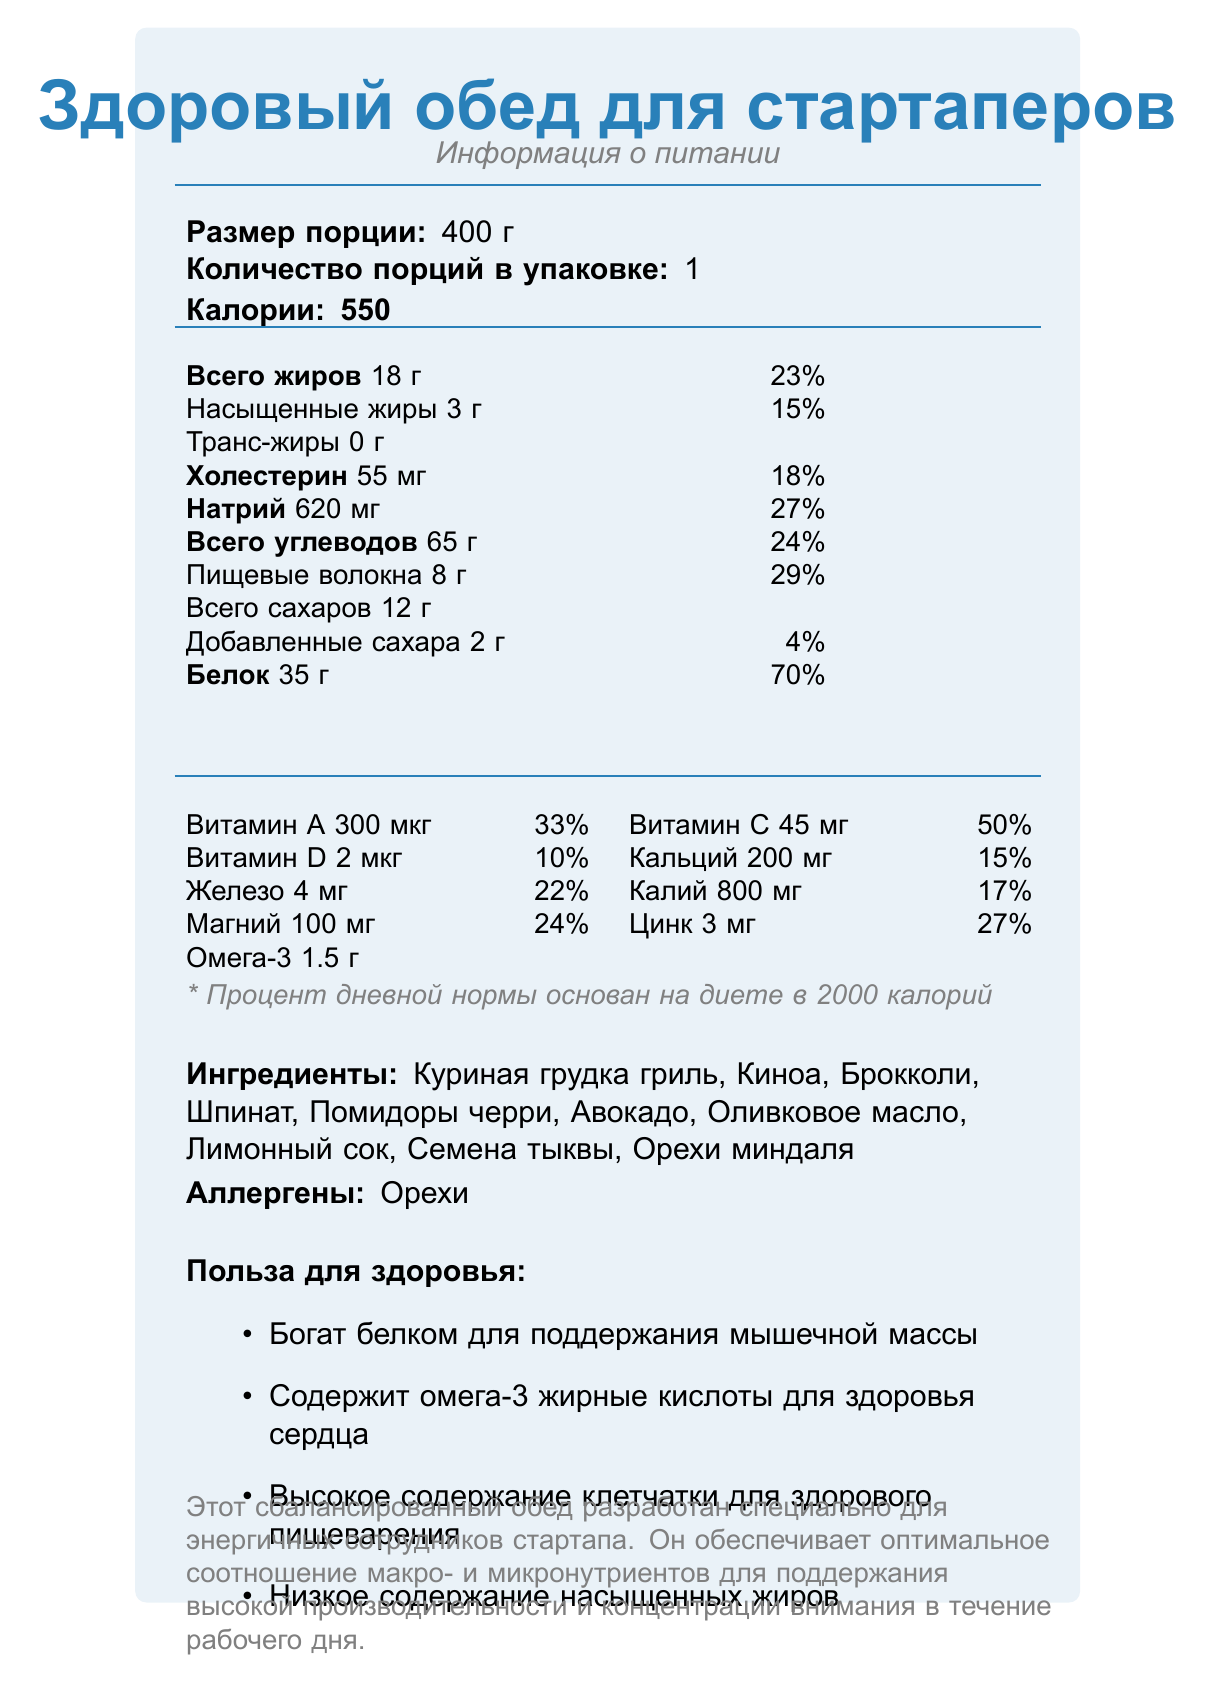what is the serving size? The label states that the serving size is 400 г.
Answer: 400 г how many calories does one serving contain? The document indicates that there are 550 calories per serving.
Answer: 550 what is the amount of protein in one serving? The label states that one serving contains 35 г of protein.
Answer: 35 г what percentage of vitamin C does one serving provide? The label shows that one serving provides 50% of the daily value for vitamin C.
Answer: 50% which ingredient might cause an allergic reaction? The list of allergens on the document includes "Орехи," which means nuts.
Answer: Орехи what is the amount of dietary fiber in one serving? The label indicates that each serving contains 8 г of dietary fiber.
Answer: 8 г what are the benefits of consuming this meal related to fiber content? A. High in protein B. High in fiber C. Contains omega-3 D. Low in calories The nutritional claims indicate a high fiber content for healthy digestion.
Answer: B how much magnesium is in one serving? A. 4 мг B. 100 мг C. 200 мг D. 50 мг The label shows that one serving contains 100 мг of magnesium.
Answer: B does this meal include any trans fats? The document explicitly states that this meal contains 0 г of trans fats.
Answer: No is this meal suitable for someone limiting their sodium intake? The meal contains 620 мг of sodium per serving, which is 27% of the daily recommended value, possibly making it unsuitable for someone limiting sodium intake.
Answer: No what are the ingredients of this meal? The list of ingredients includes these items as stated in the document.
Answer: Куриная грудка гриль, Киноа, Брокколи, Шпинат, Помидоры черри, Авокадо, Оливковое масло, Лимонный сок, Семена тыквы, Орехи миндаля summarize the main purpose of this meal. This balanced meal is specially designed for energetic startup employees, offering an optimal balance of macronutrients and micronutrients to maintain high productivity and focus throughout the workday.
Answer: Этот сбалансированный обед разработан специально для энергичных сотрудников стартапа. Он обеспечивает оптимальное соотношение макро- и микронутриентов для поддержания высокой производительности и концентрации внимания в течение рабочего дня. what is the recommended daily caloric intake on which the percentages are based? The document notes that percentage daily values are based on a 2000 calorie diet.
Answer: 2000 калорий how much omega-3 does one serving contain? The label states that one serving contains 1.5 г of omega-3.
Answer: 1.5 г how is vitamin D represented in the meal's nutritional content? The label shows 2 мкг of vitamin D, which is 10% of the daily recommended value.
Answer: 2 мкг (10% дневной нормы) what is the total carbohydrate content per serving? The document indicates that each serving has 65 г of total carbohydrates.
Answer: 65 г which micronutrient has the highest percentage of the daily value in this meal? A. Витамин A B. Витамин C C. Белок D. Клетчатка E. Железо The protein content provides 70% of the daily value, which is the highest percentage among the listed options.
Answer: C what type of oil is used as an ingredient in this meal? The ingredients list includes "Оливковое масло," which means olive oil.
Answer: Оливковое масло what macronutrient is not provided in specific amounts in this meal? The label seems to cover all macronutrients.
Answer: Cannot be determined how much potassium does one serving of this meal provide? The label indicates that each serving contains 800 мг of potassium.
Answer: 800 мг what is the primary benefit of the meal's omega-3 content? The health claims mention that the meal contains omega-3 fatty acids, which are beneficial for heart health.
Answer: Сердечное здоровье 